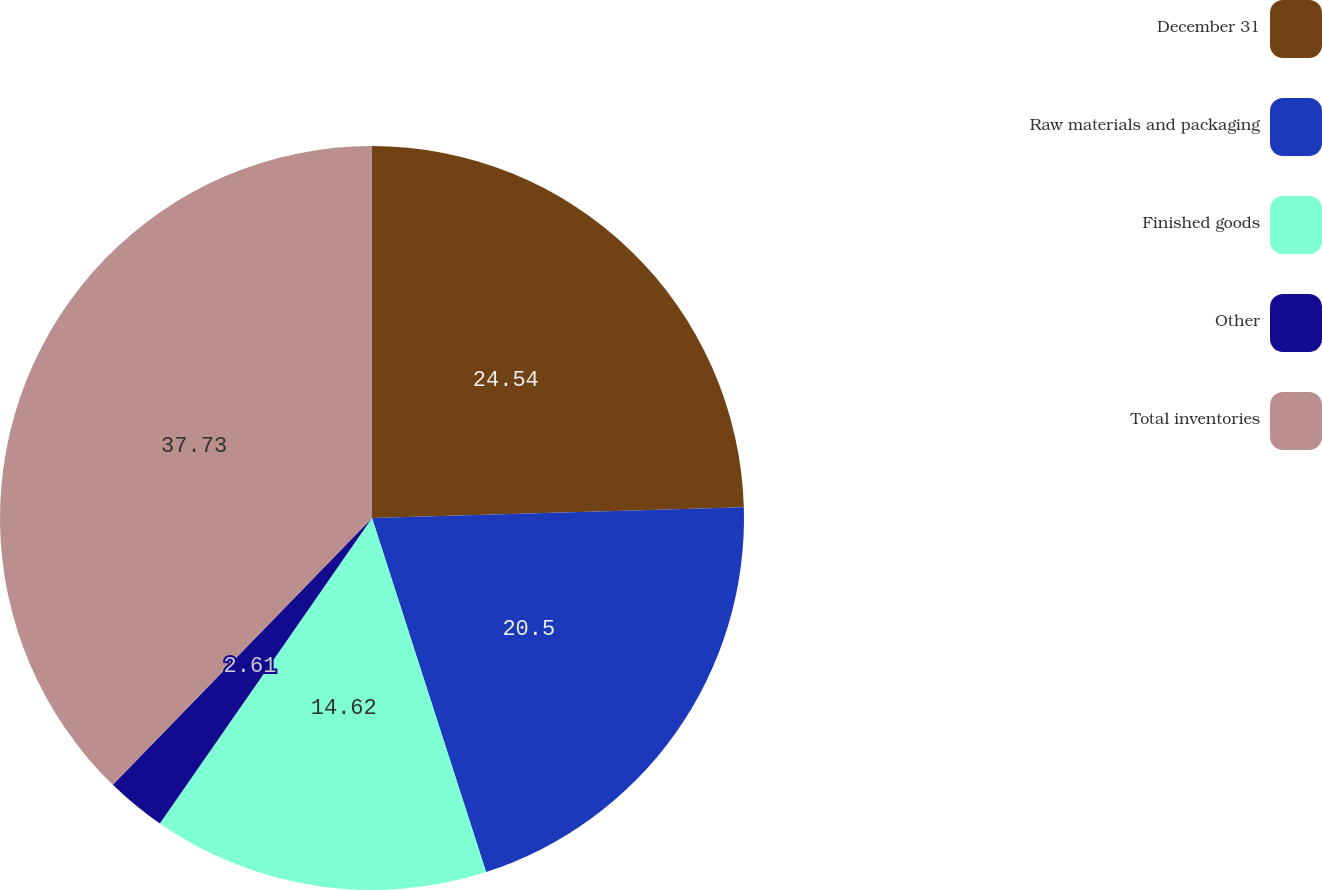Convert chart. <chart><loc_0><loc_0><loc_500><loc_500><pie_chart><fcel>December 31<fcel>Raw materials and packaging<fcel>Finished goods<fcel>Other<fcel>Total inventories<nl><fcel>24.54%<fcel>20.5%<fcel>14.62%<fcel>2.61%<fcel>37.73%<nl></chart> 